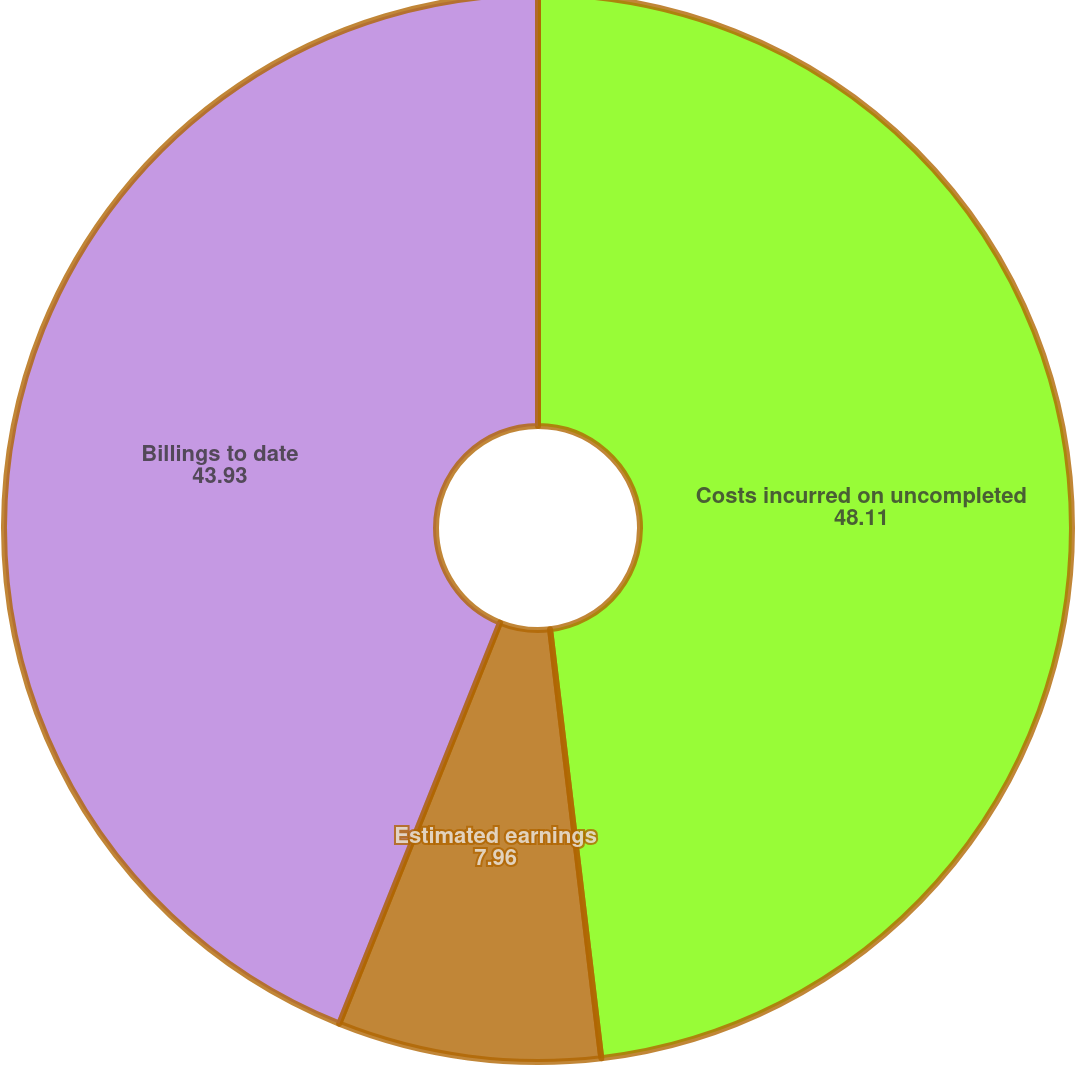Convert chart to OTSL. <chart><loc_0><loc_0><loc_500><loc_500><pie_chart><fcel>Costs incurred on uncompleted<fcel>Estimated earnings<fcel>Billings to date<nl><fcel>48.11%<fcel>7.96%<fcel>43.93%<nl></chart> 